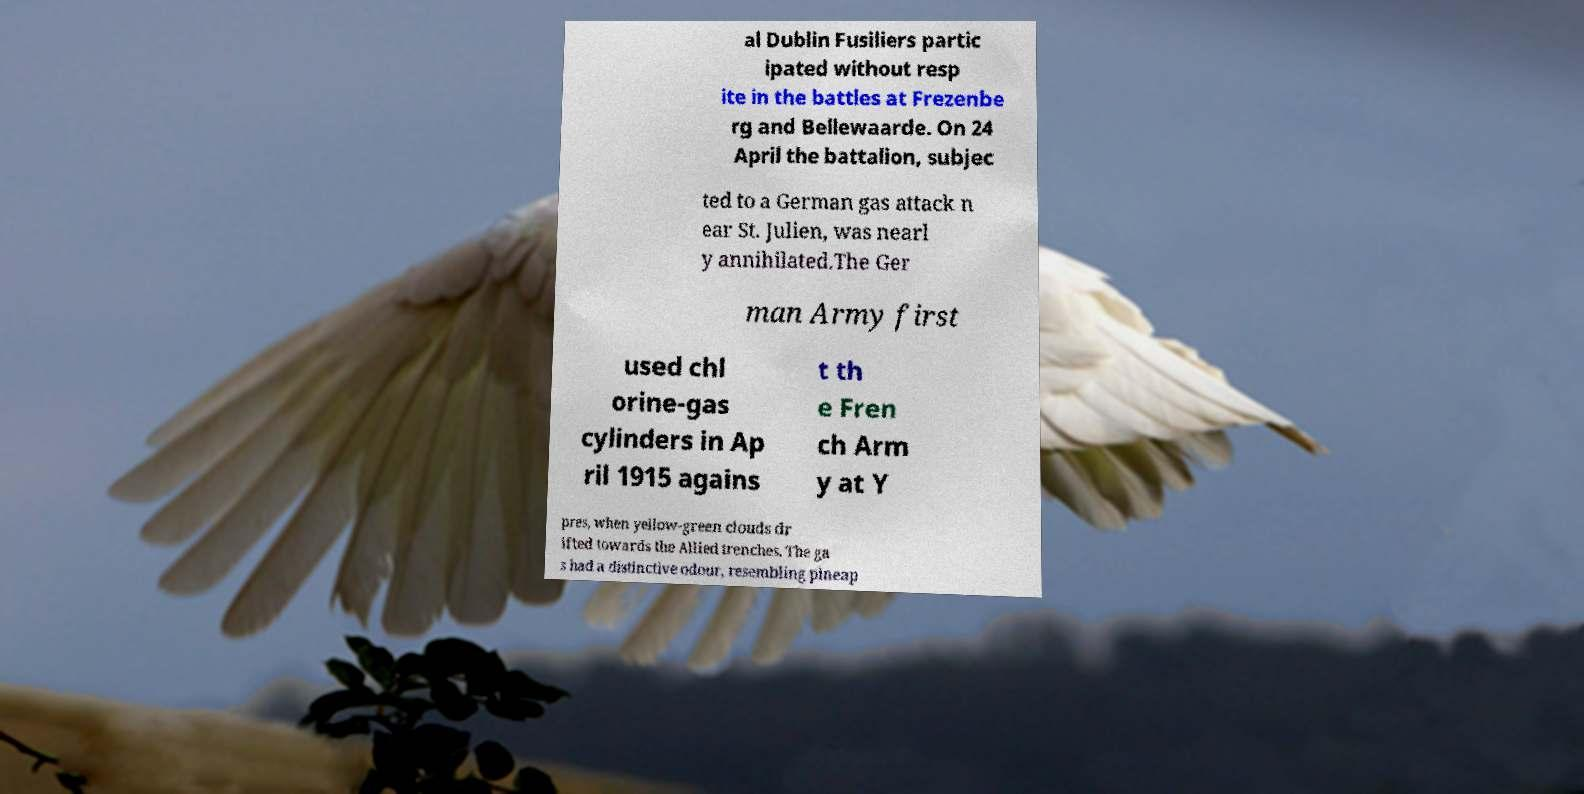For documentation purposes, I need the text within this image transcribed. Could you provide that? al Dublin Fusiliers partic ipated without resp ite in the battles at Frezenbe rg and Bellewaarde. On 24 April the battalion, subjec ted to a German gas attack n ear St. Julien, was nearl y annihilated.The Ger man Army first used chl orine-gas cylinders in Ap ril 1915 agains t th e Fren ch Arm y at Y pres, when yellow-green clouds dr ifted towards the Allied trenches. The ga s had a distinctive odour, resembling pineap 